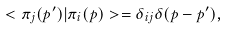<formula> <loc_0><loc_0><loc_500><loc_500>< \pi _ { j } ( p ^ { \prime } ) | \pi _ { i } ( p ) > = \delta _ { i j } \delta ( p - p ^ { \prime } ) ,</formula> 